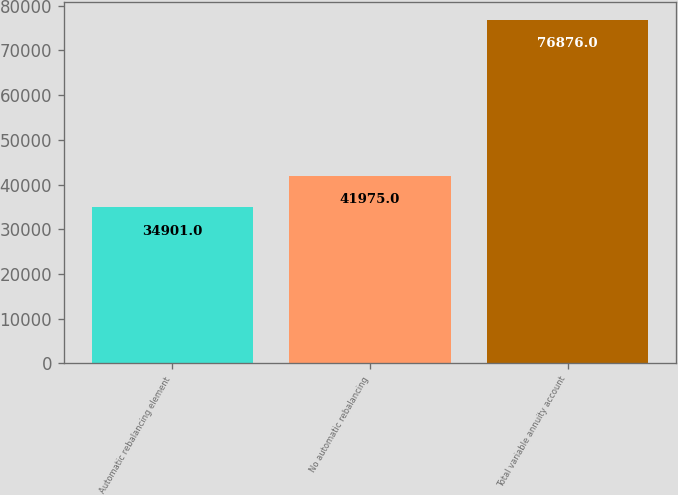<chart> <loc_0><loc_0><loc_500><loc_500><bar_chart><fcel>Automatic rebalancing element<fcel>No automatic rebalancing<fcel>Total variable annuity account<nl><fcel>34901<fcel>41975<fcel>76876<nl></chart> 